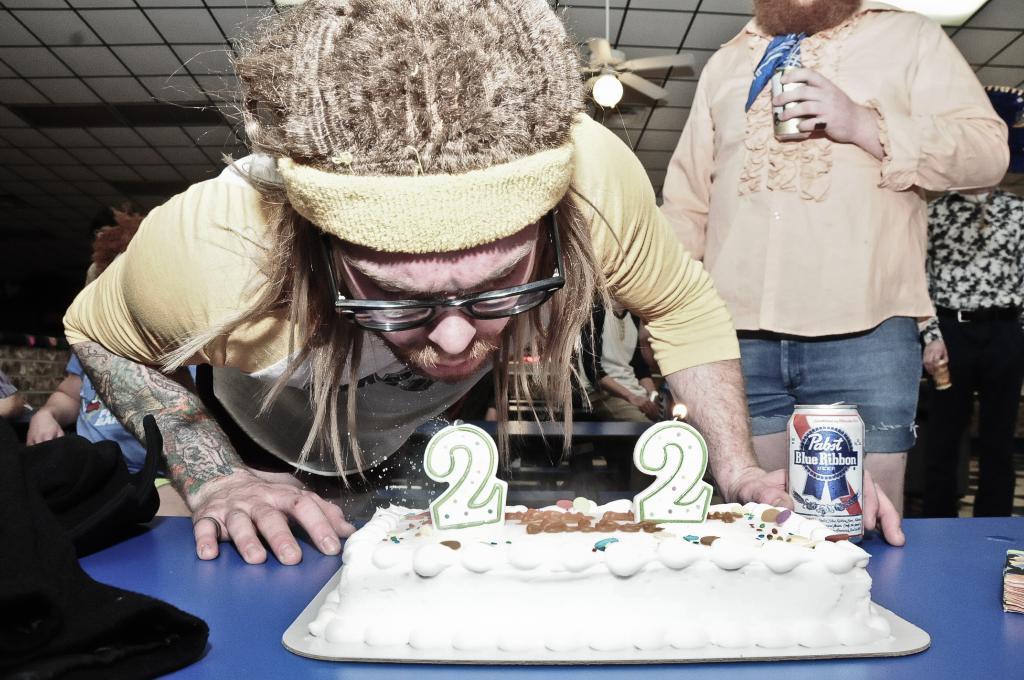Could you give a brief overview of what you see in this image? In the foreground I can see a cake on the table and two persons are holding cans in their hand. In the background I can see three persons, rooftop, tables and some objects. This image is taken may be in a hall. 